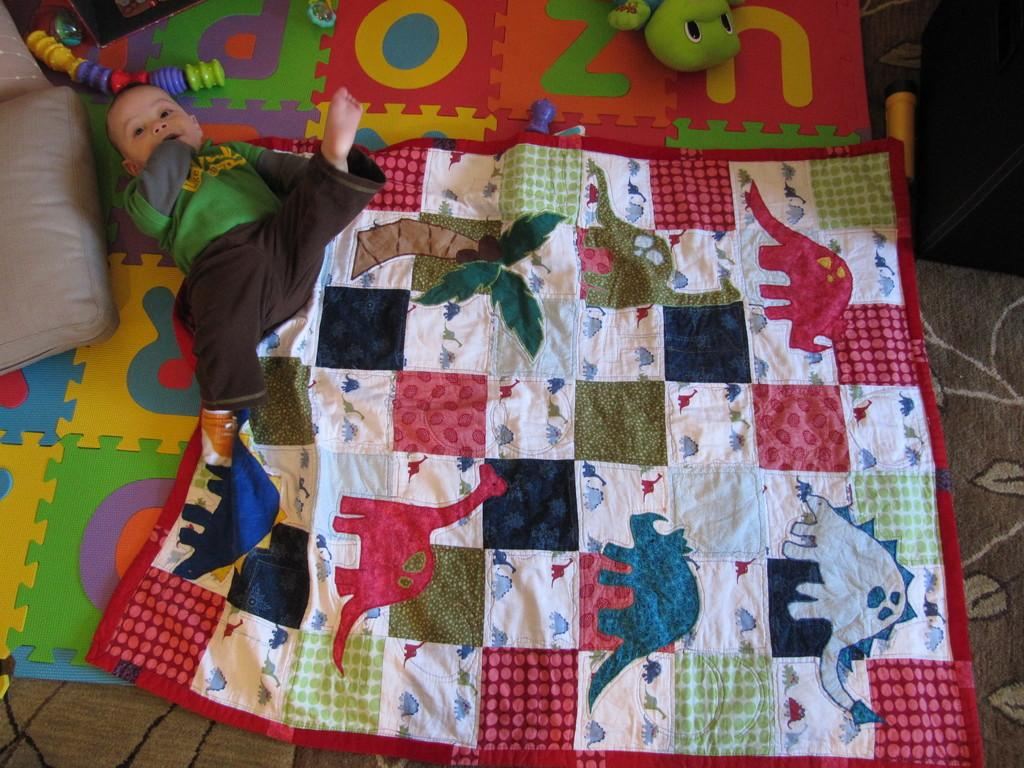What is the main subject of the image? There is a baby in the image. What is the baby lying on? The baby is lying on a cloth. What can be seen on the left side of the image? There is a pillow on the left side of the image. What type of objects are visible at the top of the image? There are toys visible at the top of the image. What type of wire is being used to hold the cabbage in the image? There is no wire or cabbage present in the image. 